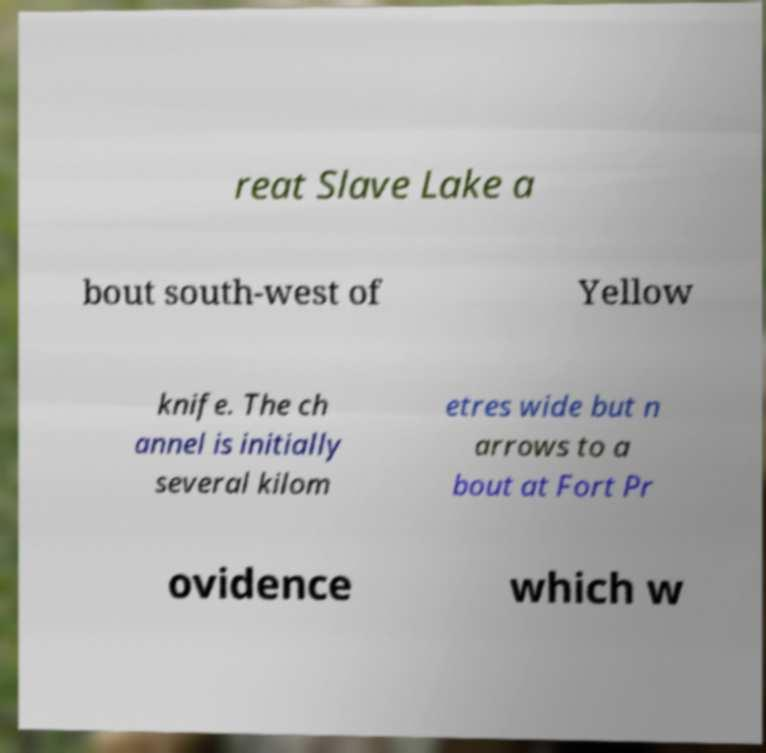For documentation purposes, I need the text within this image transcribed. Could you provide that? reat Slave Lake a bout south-west of Yellow knife. The ch annel is initially several kilom etres wide but n arrows to a bout at Fort Pr ovidence which w 